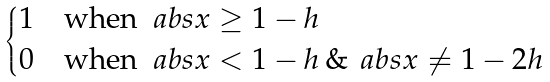<formula> <loc_0><loc_0><loc_500><loc_500>\begin{dcases} 1 & \text {when } \ a b s { x } \geq 1 - h \\ 0 & \text {when } \ a b s { x } < 1 - h \, \& \, \ a b s { x } \neq 1 - 2 h \end{dcases}</formula> 